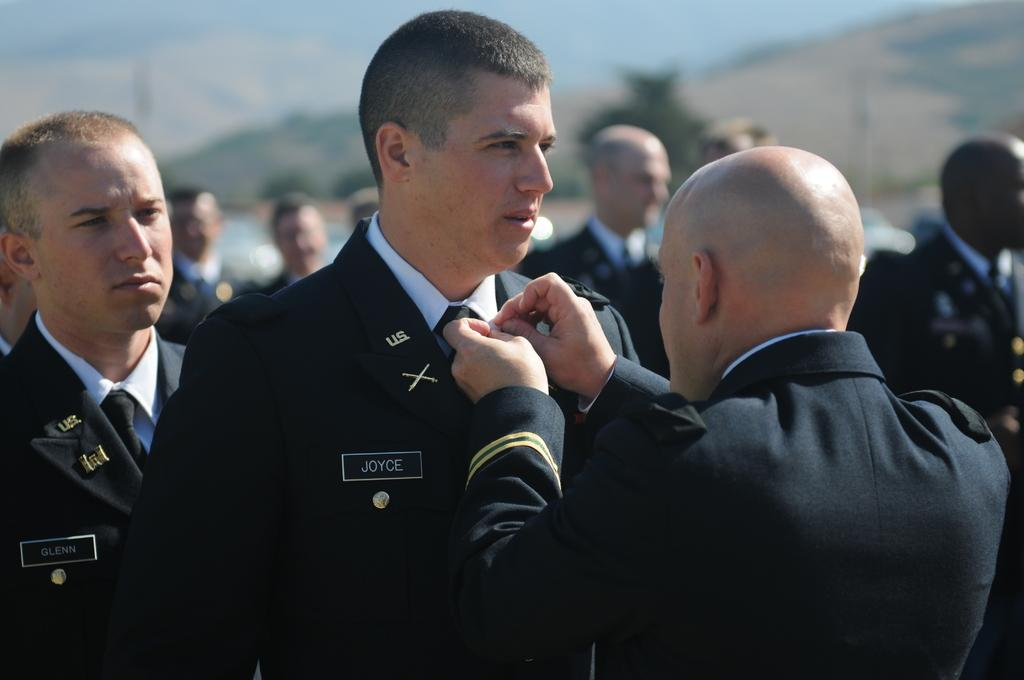What is the man in the foreground of the image doing? The man is holding another man's shirt in the image. Can you describe the people in the background of the image? There are other people in the background of the image. What type of spade is being used by the man in the image? There is no spade present in the image; the man is holding another man's shirt. 